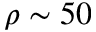Convert formula to latex. <formula><loc_0><loc_0><loc_500><loc_500>\rho \sim 5 0</formula> 